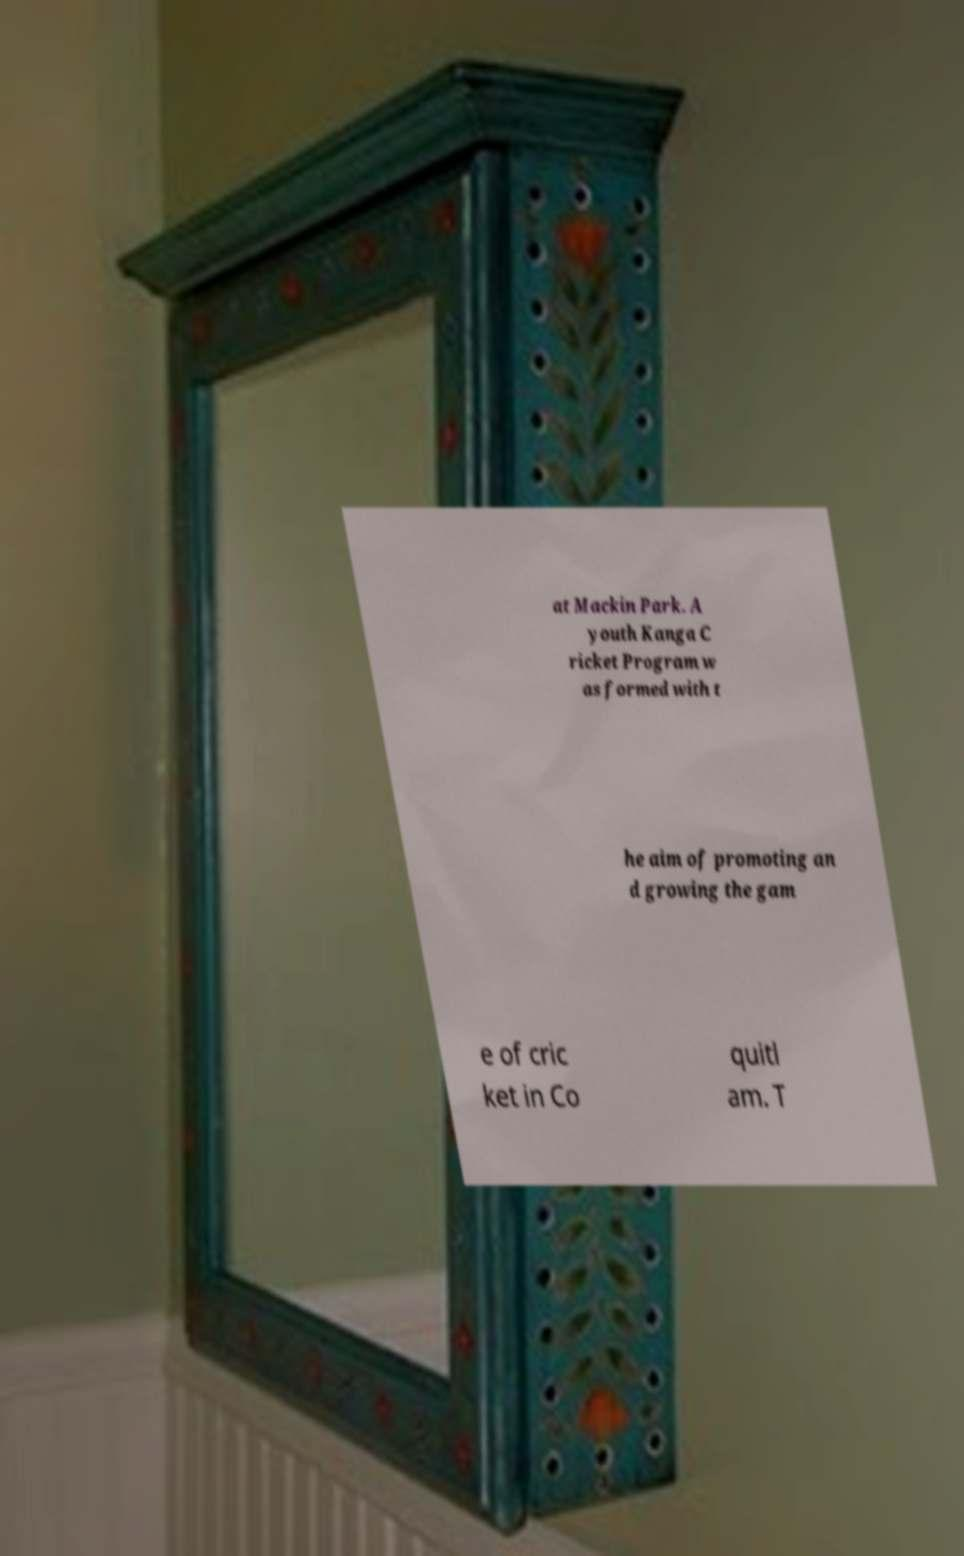For documentation purposes, I need the text within this image transcribed. Could you provide that? at Mackin Park. A youth Kanga C ricket Program w as formed with t he aim of promoting an d growing the gam e of cric ket in Co quitl am. T 